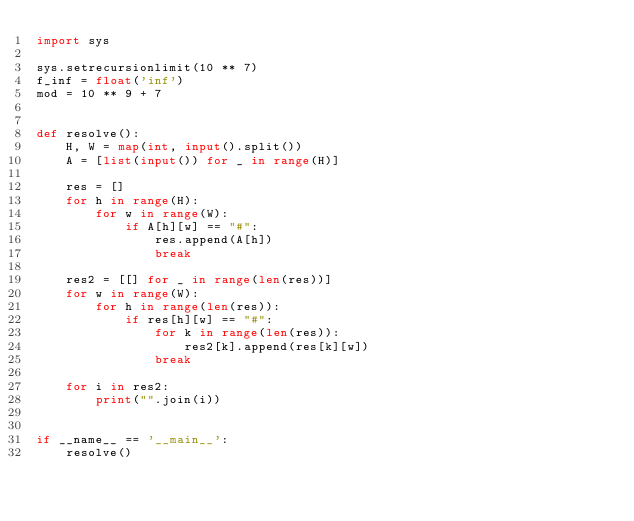<code> <loc_0><loc_0><loc_500><loc_500><_Python_>import sys

sys.setrecursionlimit(10 ** 7)
f_inf = float('inf')
mod = 10 ** 9 + 7


def resolve():
    H, W = map(int, input().split())
    A = [list(input()) for _ in range(H)]

    res = []
    for h in range(H):
        for w in range(W):
            if A[h][w] == "#":
                res.append(A[h])
                break

    res2 = [[] for _ in range(len(res))]
    for w in range(W):
        for h in range(len(res)):
            if res[h][w] == "#":
                for k in range(len(res)):
                    res2[k].append(res[k][w])
                break

    for i in res2:
        print("".join(i))


if __name__ == '__main__':
    resolve()
</code> 